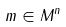<formula> <loc_0><loc_0><loc_500><loc_500>m \in M ^ { n }</formula> 